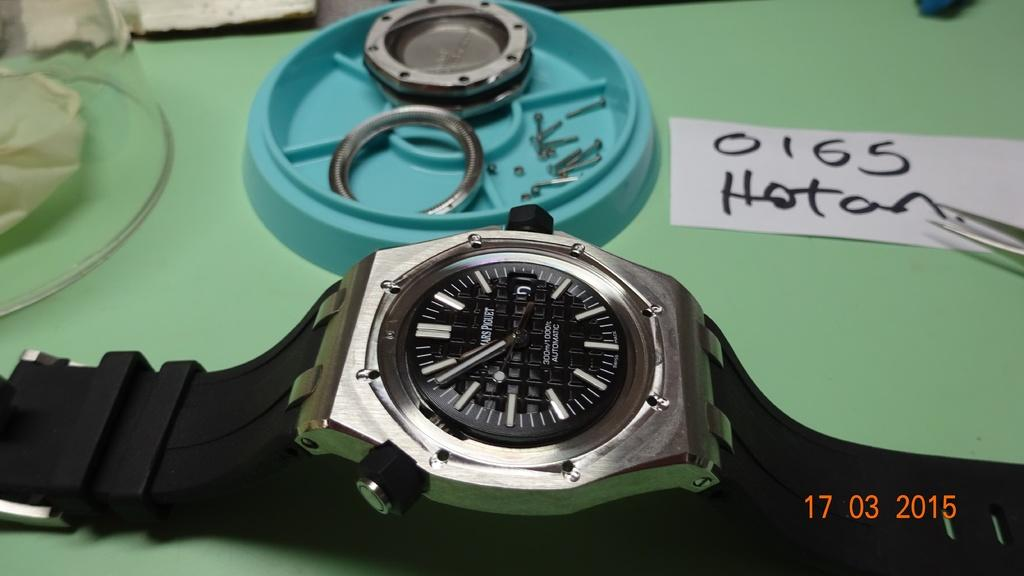<image>
Give a short and clear explanation of the subsequent image. A Mars Piguet watch with a silver bezel and black band ona green table with watch partes in a green cup. 